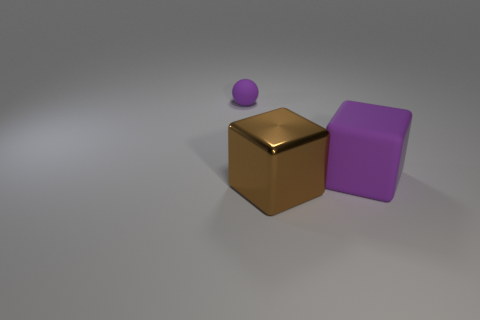Add 1 tiny purple spheres. How many objects exist? 4 Subtract all balls. How many objects are left? 2 Subtract 0 green balls. How many objects are left? 3 Subtract all tiny purple spheres. Subtract all large purple blocks. How many objects are left? 1 Add 2 brown metallic blocks. How many brown metallic blocks are left? 3 Add 3 large brown things. How many large brown things exist? 4 